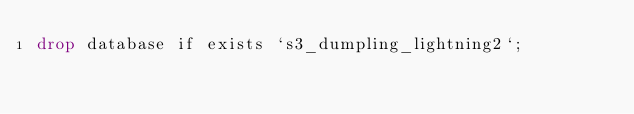Convert code to text. <code><loc_0><loc_0><loc_500><loc_500><_SQL_>drop database if exists `s3_dumpling_lightning2`;
</code> 